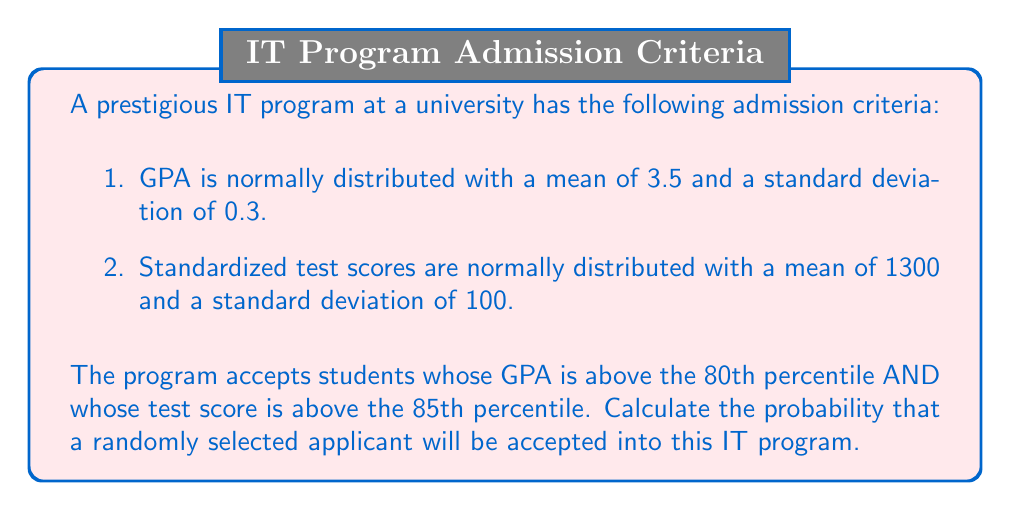What is the answer to this math problem? To solve this problem, we need to follow these steps:

1. Find the z-scores for the 80th percentile of GPA and 85th percentile of test scores.
2. Calculate the actual GPA and test score thresholds.
3. Determine the probability of meeting each criterion independently.
4. Calculate the joint probability of meeting both criteria.

Step 1: Finding z-scores
For the 80th percentile (GPA): $z_{0.80} = 0.84$ (from standard normal distribution table)
For the 85th percentile (test score): $z_{0.85} = 1.04$

Step 2: Calculating thresholds
GPA threshold: 
$$\text{GPA}_{\text{threshold}} = \mu + z\sigma = 3.5 + (0.84 \times 0.3) = 3.752$$

Test score threshold:
$$\text{Score}_{\text{threshold}} = \mu + z\sigma = 1300 + (1.04 \times 100) = 1404$$

Step 3: Probabilities of meeting each criterion
Probability of GPA above threshold:
$$P(\text{GPA} > 3.752) = 1 - 0.80 = 0.20$$

Probability of test score above threshold:
$$P(\text{Score} > 1404) = 1 - 0.85 = 0.15$$

Step 4: Joint probability
Since the criteria are independent, we multiply the individual probabilities:

$$P(\text{Accepted}) = P(\text{GPA} > 3.752 \text{ AND Score} > 1404) = 0.20 \times 0.15 = 0.03$$
Answer: The probability that a randomly selected applicant will be accepted into the IT program is 0.03 or 3%. 